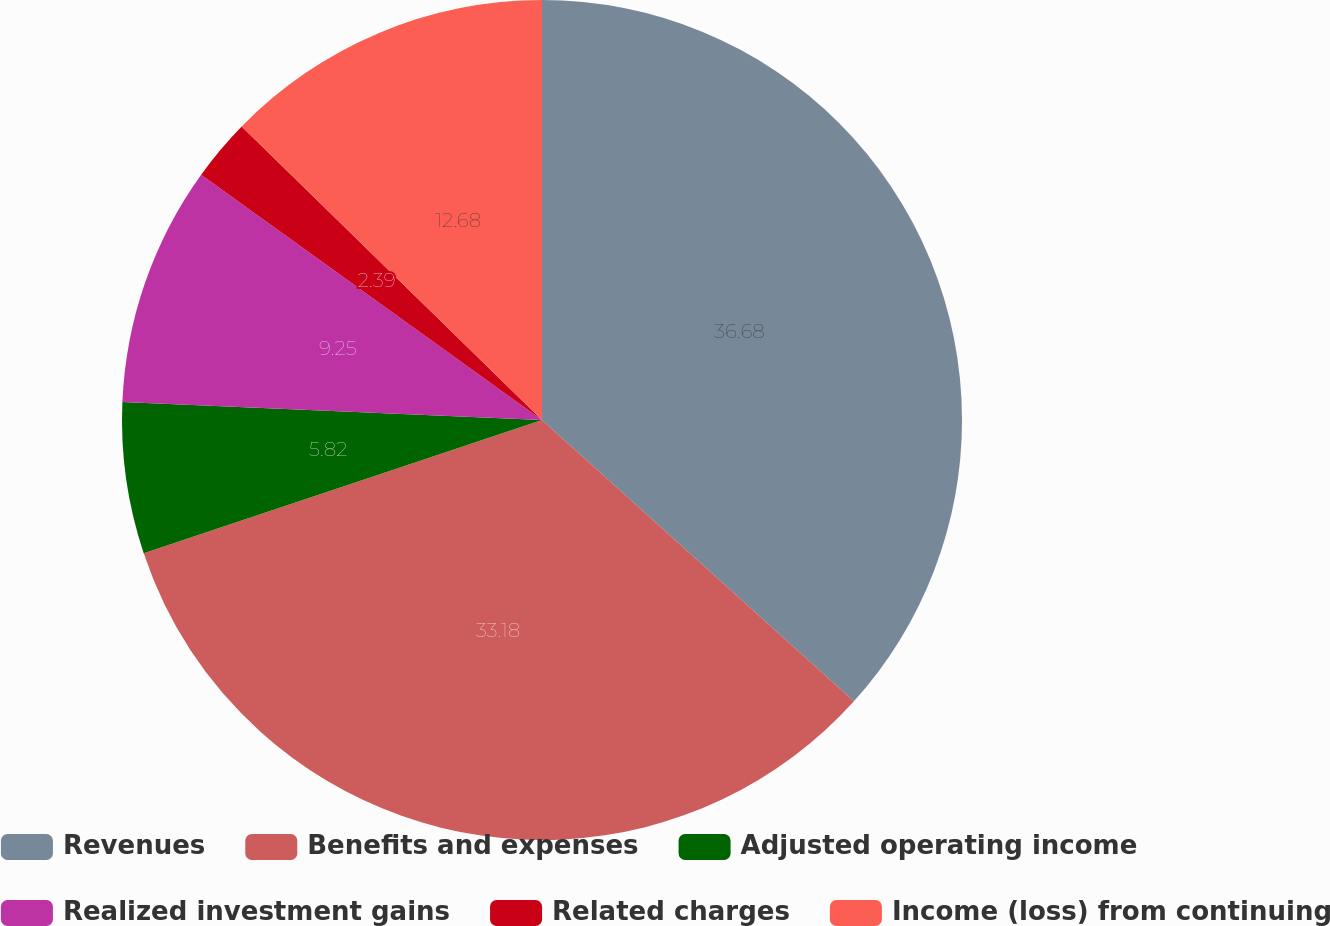Convert chart to OTSL. <chart><loc_0><loc_0><loc_500><loc_500><pie_chart><fcel>Revenues<fcel>Benefits and expenses<fcel>Adjusted operating income<fcel>Realized investment gains<fcel>Related charges<fcel>Income (loss) from continuing<nl><fcel>36.68%<fcel>33.18%<fcel>5.82%<fcel>9.25%<fcel>2.39%<fcel>12.68%<nl></chart> 